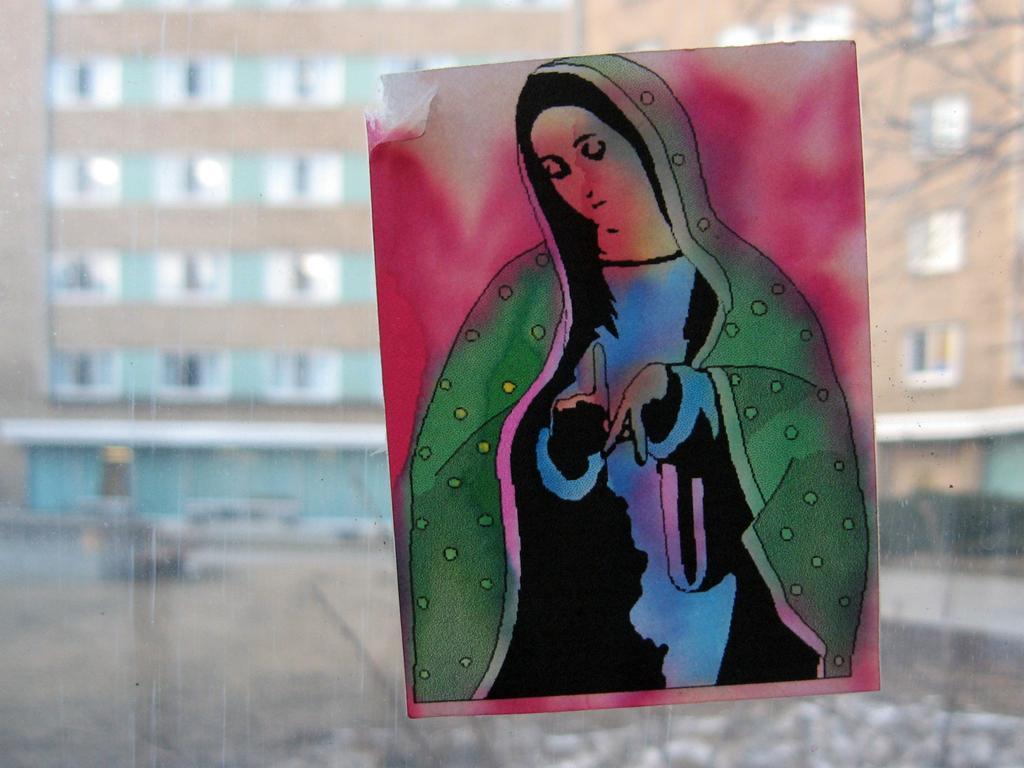Please provide a concise description of this image. In the picture we can see a glass wall to it, we can see a painting of a woman and from the glass wall we can see a part of the building with windows. 